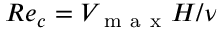<formula> <loc_0><loc_0><loc_500><loc_500>R e _ { c } = V _ { m a x } H / \nu</formula> 